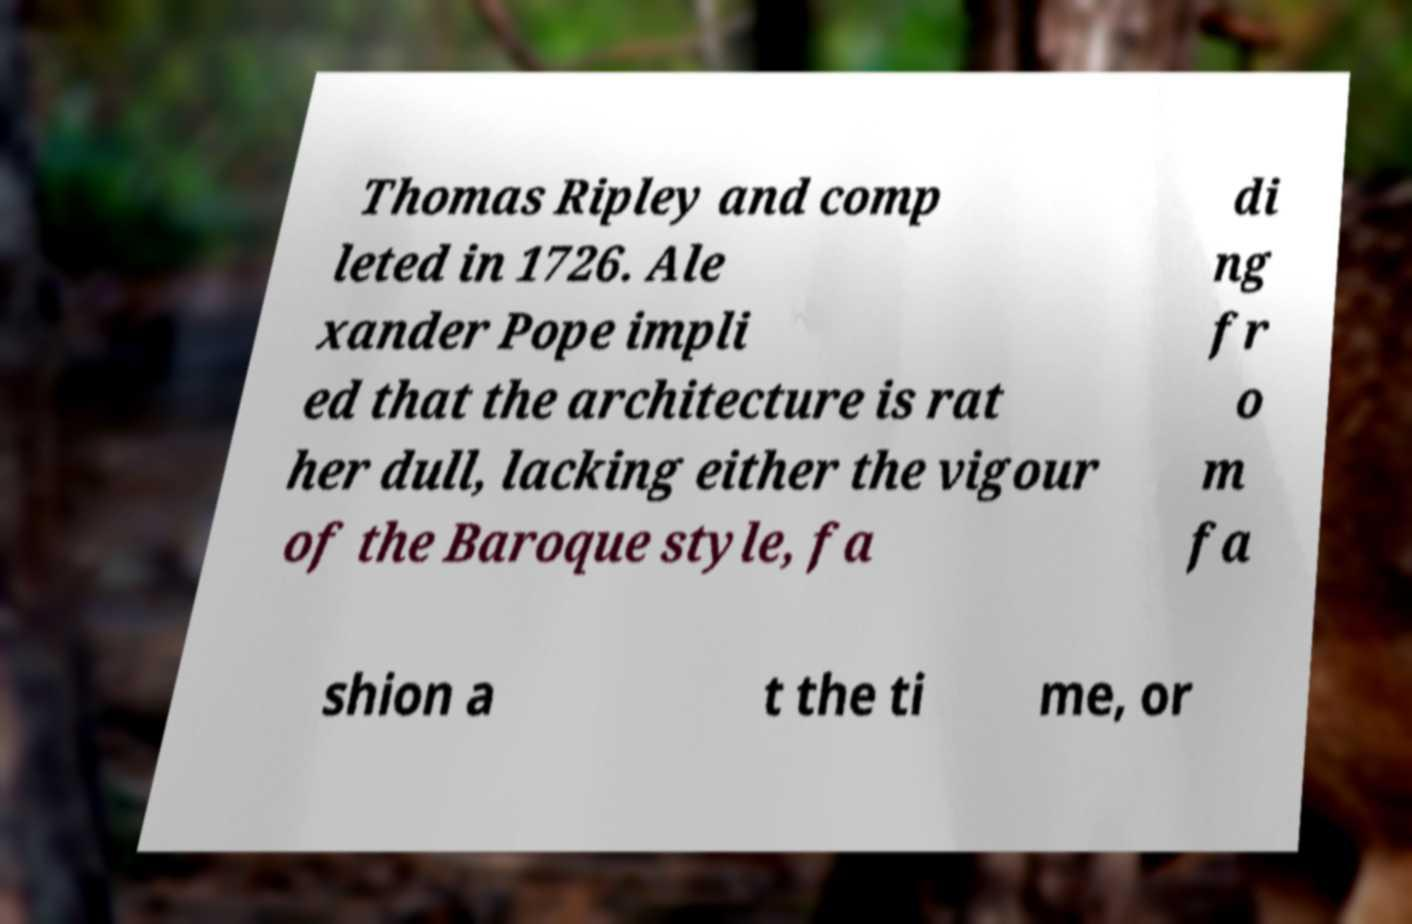Please identify and transcribe the text found in this image. Thomas Ripley and comp leted in 1726. Ale xander Pope impli ed that the architecture is rat her dull, lacking either the vigour of the Baroque style, fa di ng fr o m fa shion a t the ti me, or 